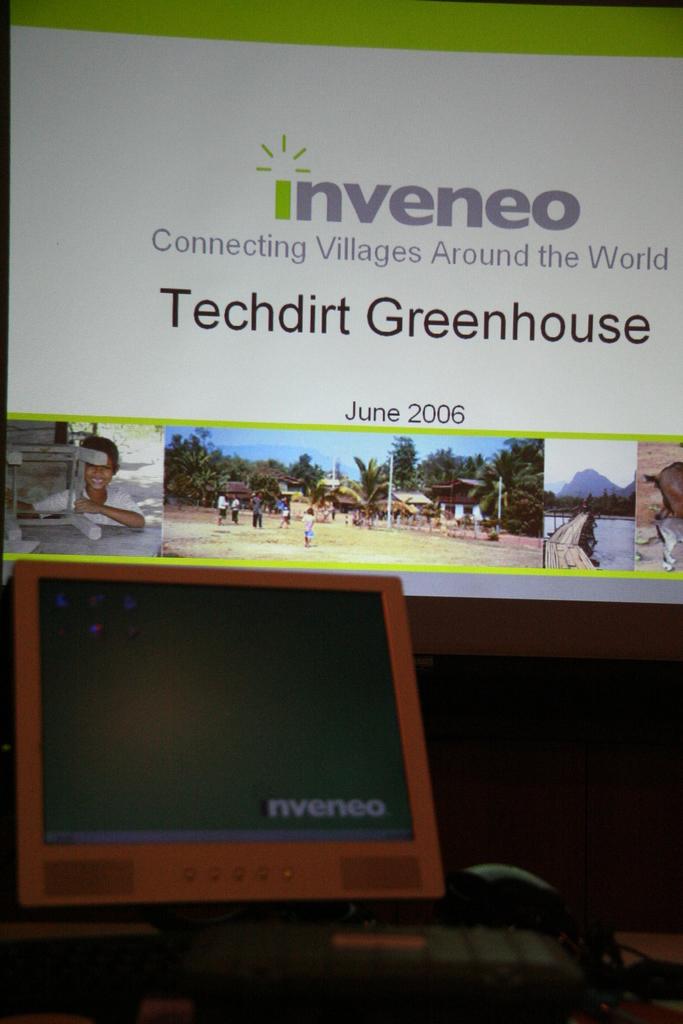Where is techdirt greenhouse located?
Ensure brevity in your answer.  Unanswerable. When is this event taking place?
Ensure brevity in your answer.  June 2006. 